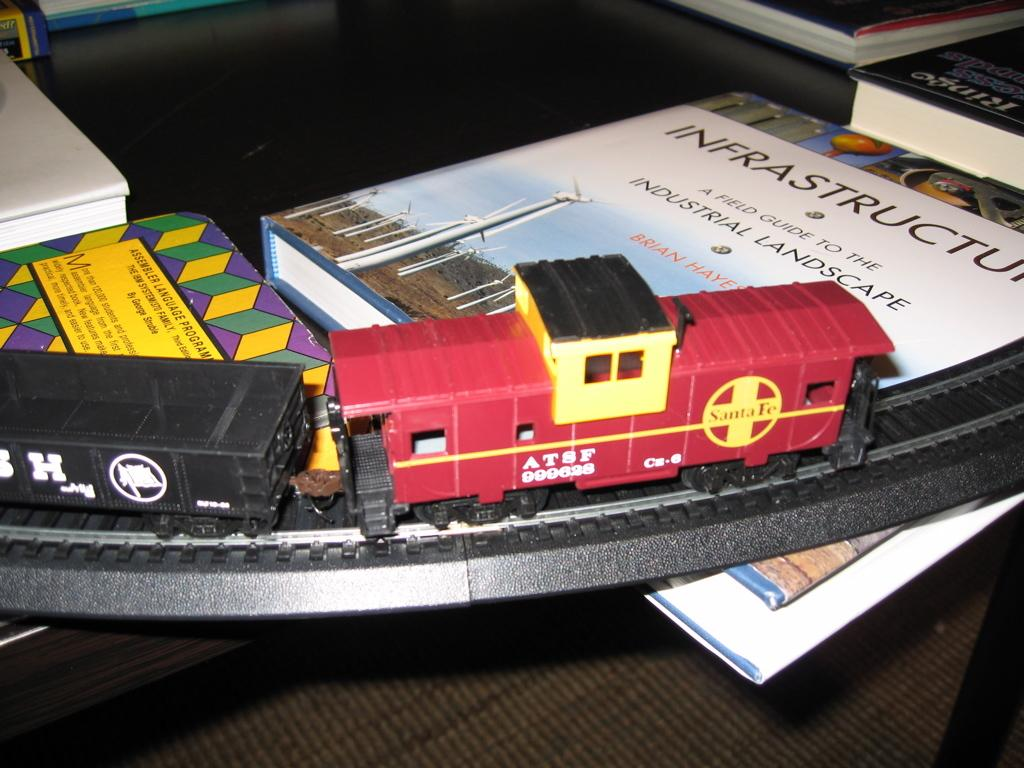<image>
Write a terse but informative summary of the picture. A model train running across several books including one about infrastructure. 